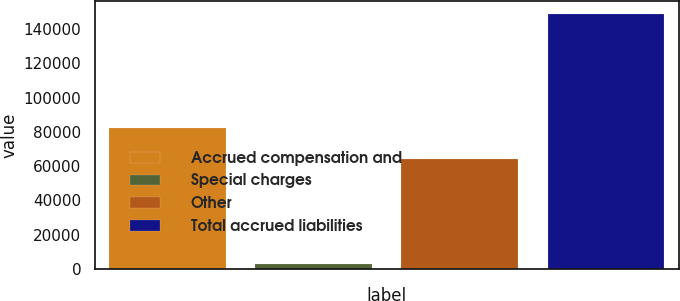Convert chart to OTSL. <chart><loc_0><loc_0><loc_500><loc_500><bar_chart><fcel>Accrued compensation and<fcel>Special charges<fcel>Other<fcel>Total accrued liabilities<nl><fcel>82027<fcel>2993<fcel>63887<fcel>148907<nl></chart> 